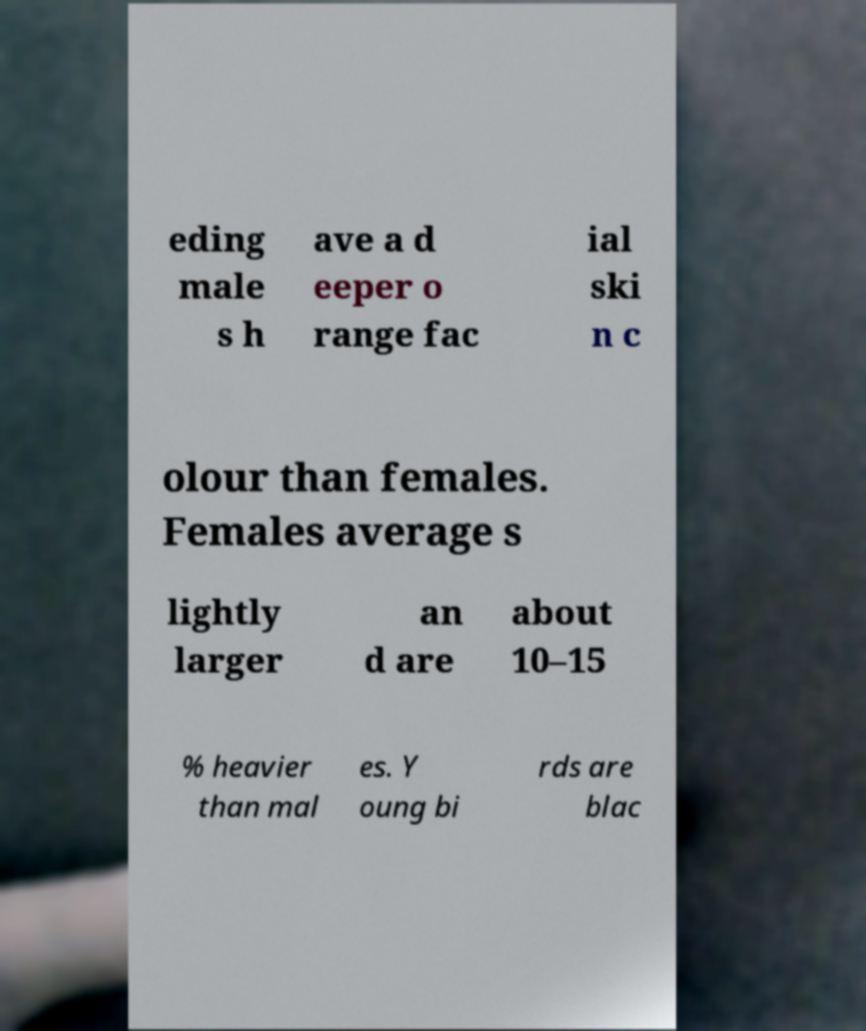What messages or text are displayed in this image? I need them in a readable, typed format. eding male s h ave a d eeper o range fac ial ski n c olour than females. Females average s lightly larger an d are about 10–15 % heavier than mal es. Y oung bi rds are blac 